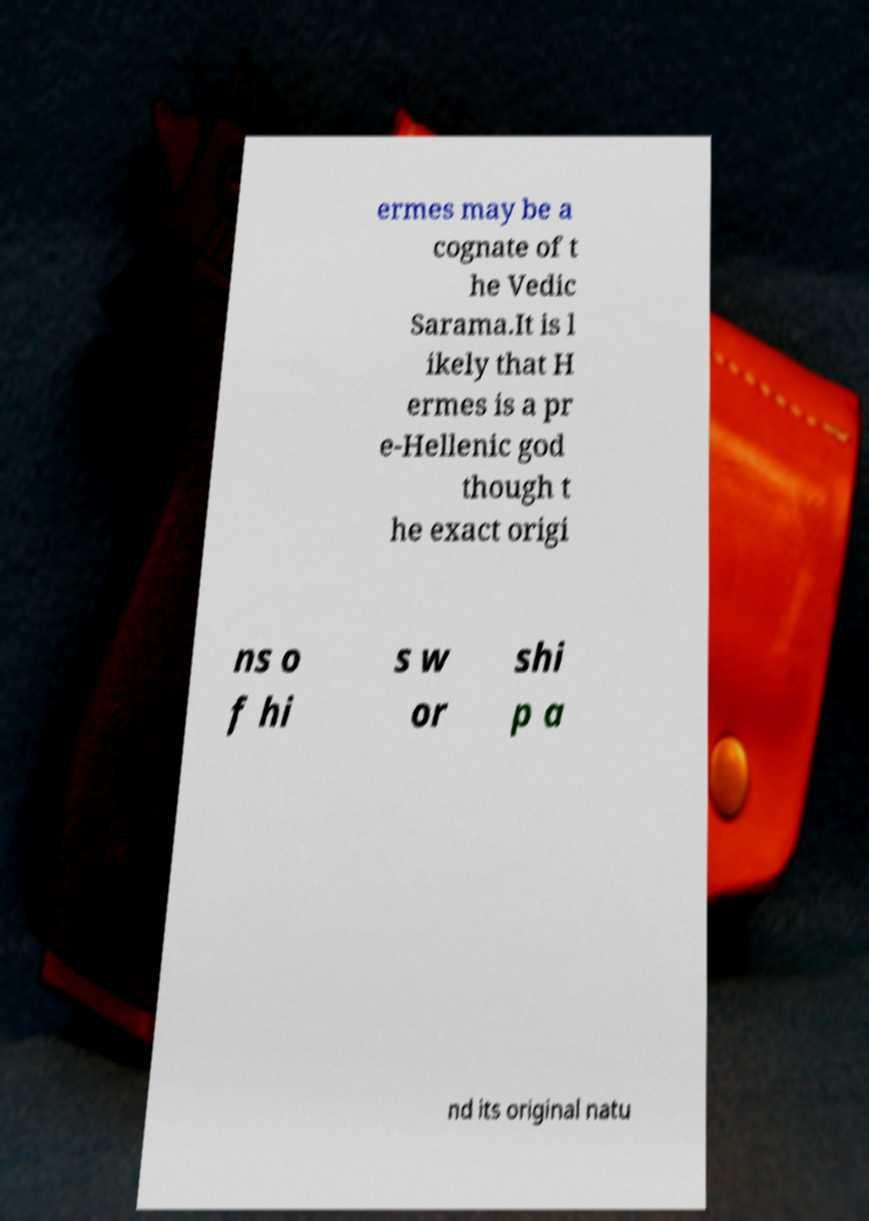Can you read and provide the text displayed in the image?This photo seems to have some interesting text. Can you extract and type it out for me? ermes may be a cognate of t he Vedic Sarama.It is l ikely that H ermes is a pr e-Hellenic god though t he exact origi ns o f hi s w or shi p a nd its original natu 